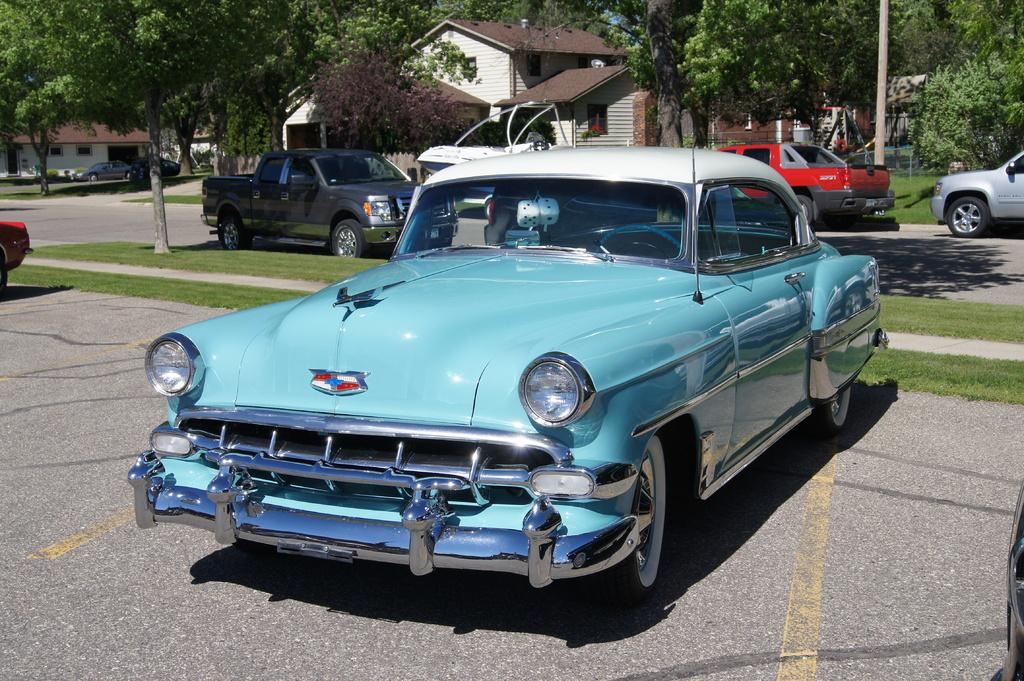What is the main subject in the center of the image? There is a car in the center of the image. What can be seen in the background of the image? There are trees, buildings, roofs, vehicles, a road, grass, and a pole in the background of the image. What type of fish can be seen swimming in the background of the image? There are no fish present in the image; it features a car in the center and various elements in the background, but no fish. 